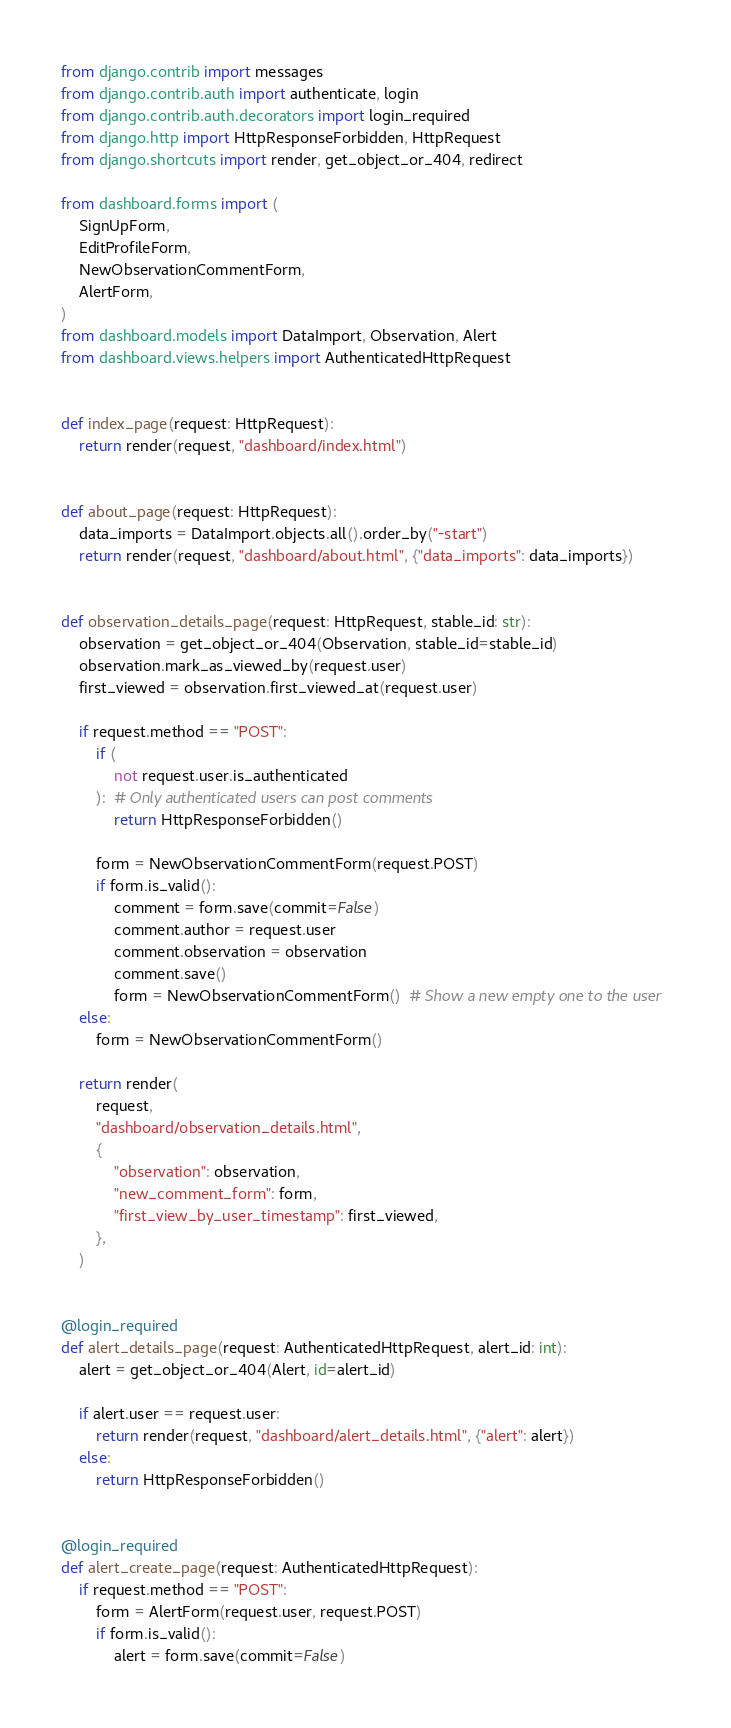<code> <loc_0><loc_0><loc_500><loc_500><_Python_>from django.contrib import messages
from django.contrib.auth import authenticate, login
from django.contrib.auth.decorators import login_required
from django.http import HttpResponseForbidden, HttpRequest
from django.shortcuts import render, get_object_or_404, redirect

from dashboard.forms import (
    SignUpForm,
    EditProfileForm,
    NewObservationCommentForm,
    AlertForm,
)
from dashboard.models import DataImport, Observation, Alert
from dashboard.views.helpers import AuthenticatedHttpRequest


def index_page(request: HttpRequest):
    return render(request, "dashboard/index.html")


def about_page(request: HttpRequest):
    data_imports = DataImport.objects.all().order_by("-start")
    return render(request, "dashboard/about.html", {"data_imports": data_imports})


def observation_details_page(request: HttpRequest, stable_id: str):
    observation = get_object_or_404(Observation, stable_id=stable_id)
    observation.mark_as_viewed_by(request.user)
    first_viewed = observation.first_viewed_at(request.user)

    if request.method == "POST":
        if (
            not request.user.is_authenticated
        ):  # Only authenticated users can post comments
            return HttpResponseForbidden()

        form = NewObservationCommentForm(request.POST)
        if form.is_valid():
            comment = form.save(commit=False)
            comment.author = request.user
            comment.observation = observation
            comment.save()
            form = NewObservationCommentForm()  # Show a new empty one to the user
    else:
        form = NewObservationCommentForm()

    return render(
        request,
        "dashboard/observation_details.html",
        {
            "observation": observation,
            "new_comment_form": form,
            "first_view_by_user_timestamp": first_viewed,
        },
    )


@login_required
def alert_details_page(request: AuthenticatedHttpRequest, alert_id: int):
    alert = get_object_or_404(Alert, id=alert_id)

    if alert.user == request.user:
        return render(request, "dashboard/alert_details.html", {"alert": alert})
    else:
        return HttpResponseForbidden()


@login_required
def alert_create_page(request: AuthenticatedHttpRequest):
    if request.method == "POST":
        form = AlertForm(request.user, request.POST)
        if form.is_valid():
            alert = form.save(commit=False)</code> 